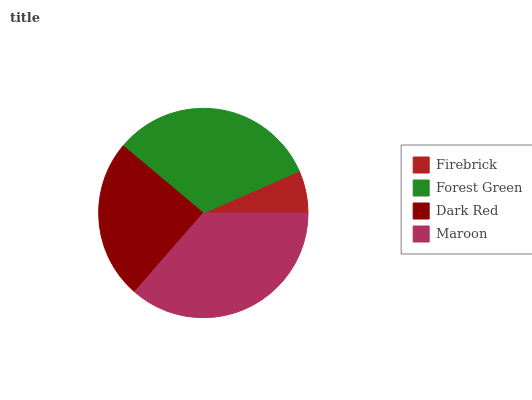Is Firebrick the minimum?
Answer yes or no. Yes. Is Maroon the maximum?
Answer yes or no. Yes. Is Forest Green the minimum?
Answer yes or no. No. Is Forest Green the maximum?
Answer yes or no. No. Is Forest Green greater than Firebrick?
Answer yes or no. Yes. Is Firebrick less than Forest Green?
Answer yes or no. Yes. Is Firebrick greater than Forest Green?
Answer yes or no. No. Is Forest Green less than Firebrick?
Answer yes or no. No. Is Forest Green the high median?
Answer yes or no. Yes. Is Dark Red the low median?
Answer yes or no. Yes. Is Dark Red the high median?
Answer yes or no. No. Is Forest Green the low median?
Answer yes or no. No. 